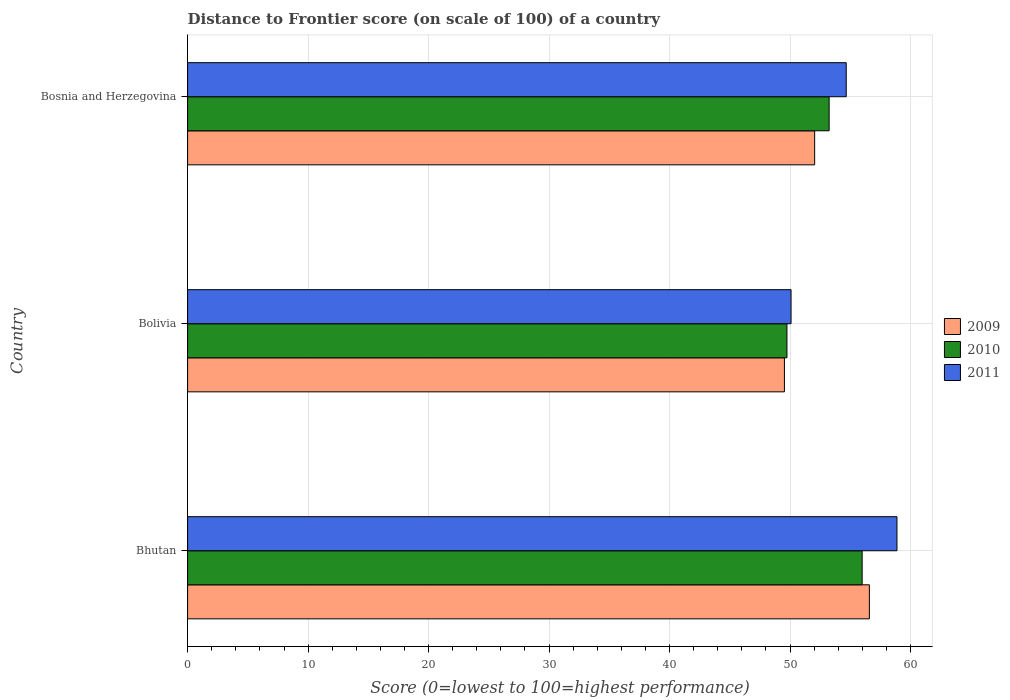How many groups of bars are there?
Give a very brief answer. 3. Are the number of bars per tick equal to the number of legend labels?
Make the answer very short. Yes. Are the number of bars on each tick of the Y-axis equal?
Your answer should be compact. Yes. What is the distance to frontier score of in 2010 in Bolivia?
Give a very brief answer. 49.74. Across all countries, what is the maximum distance to frontier score of in 2010?
Give a very brief answer. 55.98. Across all countries, what is the minimum distance to frontier score of in 2009?
Keep it short and to the point. 49.53. In which country was the distance to frontier score of in 2009 maximum?
Your response must be concise. Bhutan. What is the total distance to frontier score of in 2010 in the graph?
Make the answer very short. 158.96. What is the difference between the distance to frontier score of in 2011 in Bhutan and that in Bolivia?
Ensure brevity in your answer.  8.79. What is the difference between the distance to frontier score of in 2010 in Bhutan and the distance to frontier score of in 2009 in Bosnia and Herzegovina?
Provide a short and direct response. 3.94. What is the average distance to frontier score of in 2011 per country?
Give a very brief answer. 54.54. What is the difference between the distance to frontier score of in 2009 and distance to frontier score of in 2010 in Bolivia?
Make the answer very short. -0.21. What is the ratio of the distance to frontier score of in 2010 in Bolivia to that in Bosnia and Herzegovina?
Your answer should be very brief. 0.93. Is the distance to frontier score of in 2009 in Bhutan less than that in Bosnia and Herzegovina?
Keep it short and to the point. No. Is the difference between the distance to frontier score of in 2009 in Bhutan and Bolivia greater than the difference between the distance to frontier score of in 2010 in Bhutan and Bolivia?
Give a very brief answer. Yes. What is the difference between the highest and the second highest distance to frontier score of in 2010?
Make the answer very short. 2.74. What is the difference between the highest and the lowest distance to frontier score of in 2009?
Your answer should be very brief. 7.05. Is the sum of the distance to frontier score of in 2010 in Bolivia and Bosnia and Herzegovina greater than the maximum distance to frontier score of in 2011 across all countries?
Make the answer very short. Yes. What does the 2nd bar from the bottom in Bolivia represents?
Provide a short and direct response. 2010. How many bars are there?
Keep it short and to the point. 9. How many countries are there in the graph?
Offer a very short reply. 3. What is the difference between two consecutive major ticks on the X-axis?
Give a very brief answer. 10. Does the graph contain grids?
Give a very brief answer. Yes. Where does the legend appear in the graph?
Provide a short and direct response. Center right. How many legend labels are there?
Your answer should be very brief. 3. What is the title of the graph?
Offer a very short reply. Distance to Frontier score (on scale of 100) of a country. Does "1967" appear as one of the legend labels in the graph?
Offer a very short reply. No. What is the label or title of the X-axis?
Offer a terse response. Score (0=lowest to 100=highest performance). What is the Score (0=lowest to 100=highest performance) of 2009 in Bhutan?
Your response must be concise. 56.58. What is the Score (0=lowest to 100=highest performance) of 2010 in Bhutan?
Provide a short and direct response. 55.98. What is the Score (0=lowest to 100=highest performance) in 2011 in Bhutan?
Provide a short and direct response. 58.87. What is the Score (0=lowest to 100=highest performance) in 2009 in Bolivia?
Give a very brief answer. 49.53. What is the Score (0=lowest to 100=highest performance) of 2010 in Bolivia?
Offer a very short reply. 49.74. What is the Score (0=lowest to 100=highest performance) in 2011 in Bolivia?
Offer a terse response. 50.08. What is the Score (0=lowest to 100=highest performance) of 2009 in Bosnia and Herzegovina?
Give a very brief answer. 52.04. What is the Score (0=lowest to 100=highest performance) of 2010 in Bosnia and Herzegovina?
Give a very brief answer. 53.24. What is the Score (0=lowest to 100=highest performance) of 2011 in Bosnia and Herzegovina?
Your response must be concise. 54.66. Across all countries, what is the maximum Score (0=lowest to 100=highest performance) in 2009?
Offer a terse response. 56.58. Across all countries, what is the maximum Score (0=lowest to 100=highest performance) of 2010?
Ensure brevity in your answer.  55.98. Across all countries, what is the maximum Score (0=lowest to 100=highest performance) of 2011?
Your answer should be compact. 58.87. Across all countries, what is the minimum Score (0=lowest to 100=highest performance) of 2009?
Your answer should be compact. 49.53. Across all countries, what is the minimum Score (0=lowest to 100=highest performance) in 2010?
Ensure brevity in your answer.  49.74. Across all countries, what is the minimum Score (0=lowest to 100=highest performance) of 2011?
Your answer should be compact. 50.08. What is the total Score (0=lowest to 100=highest performance) of 2009 in the graph?
Provide a short and direct response. 158.15. What is the total Score (0=lowest to 100=highest performance) of 2010 in the graph?
Your answer should be compact. 158.96. What is the total Score (0=lowest to 100=highest performance) of 2011 in the graph?
Provide a succinct answer. 163.61. What is the difference between the Score (0=lowest to 100=highest performance) of 2009 in Bhutan and that in Bolivia?
Ensure brevity in your answer.  7.05. What is the difference between the Score (0=lowest to 100=highest performance) in 2010 in Bhutan and that in Bolivia?
Provide a succinct answer. 6.24. What is the difference between the Score (0=lowest to 100=highest performance) of 2011 in Bhutan and that in Bolivia?
Your answer should be compact. 8.79. What is the difference between the Score (0=lowest to 100=highest performance) in 2009 in Bhutan and that in Bosnia and Herzegovina?
Offer a very short reply. 4.54. What is the difference between the Score (0=lowest to 100=highest performance) of 2010 in Bhutan and that in Bosnia and Herzegovina?
Keep it short and to the point. 2.74. What is the difference between the Score (0=lowest to 100=highest performance) in 2011 in Bhutan and that in Bosnia and Herzegovina?
Offer a terse response. 4.21. What is the difference between the Score (0=lowest to 100=highest performance) in 2009 in Bolivia and that in Bosnia and Herzegovina?
Your answer should be compact. -2.51. What is the difference between the Score (0=lowest to 100=highest performance) in 2011 in Bolivia and that in Bosnia and Herzegovina?
Provide a short and direct response. -4.58. What is the difference between the Score (0=lowest to 100=highest performance) of 2009 in Bhutan and the Score (0=lowest to 100=highest performance) of 2010 in Bolivia?
Ensure brevity in your answer.  6.84. What is the difference between the Score (0=lowest to 100=highest performance) in 2009 in Bhutan and the Score (0=lowest to 100=highest performance) in 2011 in Bolivia?
Your answer should be compact. 6.5. What is the difference between the Score (0=lowest to 100=highest performance) of 2010 in Bhutan and the Score (0=lowest to 100=highest performance) of 2011 in Bolivia?
Your response must be concise. 5.9. What is the difference between the Score (0=lowest to 100=highest performance) in 2009 in Bhutan and the Score (0=lowest to 100=highest performance) in 2010 in Bosnia and Herzegovina?
Give a very brief answer. 3.34. What is the difference between the Score (0=lowest to 100=highest performance) of 2009 in Bhutan and the Score (0=lowest to 100=highest performance) of 2011 in Bosnia and Herzegovina?
Your answer should be compact. 1.92. What is the difference between the Score (0=lowest to 100=highest performance) of 2010 in Bhutan and the Score (0=lowest to 100=highest performance) of 2011 in Bosnia and Herzegovina?
Make the answer very short. 1.32. What is the difference between the Score (0=lowest to 100=highest performance) in 2009 in Bolivia and the Score (0=lowest to 100=highest performance) in 2010 in Bosnia and Herzegovina?
Offer a terse response. -3.71. What is the difference between the Score (0=lowest to 100=highest performance) of 2009 in Bolivia and the Score (0=lowest to 100=highest performance) of 2011 in Bosnia and Herzegovina?
Offer a very short reply. -5.13. What is the difference between the Score (0=lowest to 100=highest performance) of 2010 in Bolivia and the Score (0=lowest to 100=highest performance) of 2011 in Bosnia and Herzegovina?
Your answer should be very brief. -4.92. What is the average Score (0=lowest to 100=highest performance) of 2009 per country?
Keep it short and to the point. 52.72. What is the average Score (0=lowest to 100=highest performance) of 2010 per country?
Ensure brevity in your answer.  52.99. What is the average Score (0=lowest to 100=highest performance) of 2011 per country?
Give a very brief answer. 54.54. What is the difference between the Score (0=lowest to 100=highest performance) of 2009 and Score (0=lowest to 100=highest performance) of 2011 in Bhutan?
Provide a short and direct response. -2.29. What is the difference between the Score (0=lowest to 100=highest performance) of 2010 and Score (0=lowest to 100=highest performance) of 2011 in Bhutan?
Offer a terse response. -2.89. What is the difference between the Score (0=lowest to 100=highest performance) in 2009 and Score (0=lowest to 100=highest performance) in 2010 in Bolivia?
Keep it short and to the point. -0.21. What is the difference between the Score (0=lowest to 100=highest performance) of 2009 and Score (0=lowest to 100=highest performance) of 2011 in Bolivia?
Give a very brief answer. -0.55. What is the difference between the Score (0=lowest to 100=highest performance) in 2010 and Score (0=lowest to 100=highest performance) in 2011 in Bolivia?
Make the answer very short. -0.34. What is the difference between the Score (0=lowest to 100=highest performance) in 2009 and Score (0=lowest to 100=highest performance) in 2011 in Bosnia and Herzegovina?
Provide a short and direct response. -2.62. What is the difference between the Score (0=lowest to 100=highest performance) in 2010 and Score (0=lowest to 100=highest performance) in 2011 in Bosnia and Herzegovina?
Your answer should be very brief. -1.42. What is the ratio of the Score (0=lowest to 100=highest performance) of 2009 in Bhutan to that in Bolivia?
Your answer should be compact. 1.14. What is the ratio of the Score (0=lowest to 100=highest performance) of 2010 in Bhutan to that in Bolivia?
Offer a very short reply. 1.13. What is the ratio of the Score (0=lowest to 100=highest performance) of 2011 in Bhutan to that in Bolivia?
Provide a short and direct response. 1.18. What is the ratio of the Score (0=lowest to 100=highest performance) in 2009 in Bhutan to that in Bosnia and Herzegovina?
Your answer should be compact. 1.09. What is the ratio of the Score (0=lowest to 100=highest performance) of 2010 in Bhutan to that in Bosnia and Herzegovina?
Offer a very short reply. 1.05. What is the ratio of the Score (0=lowest to 100=highest performance) of 2011 in Bhutan to that in Bosnia and Herzegovina?
Keep it short and to the point. 1.08. What is the ratio of the Score (0=lowest to 100=highest performance) in 2009 in Bolivia to that in Bosnia and Herzegovina?
Provide a succinct answer. 0.95. What is the ratio of the Score (0=lowest to 100=highest performance) of 2010 in Bolivia to that in Bosnia and Herzegovina?
Offer a very short reply. 0.93. What is the ratio of the Score (0=lowest to 100=highest performance) of 2011 in Bolivia to that in Bosnia and Herzegovina?
Your answer should be compact. 0.92. What is the difference between the highest and the second highest Score (0=lowest to 100=highest performance) in 2009?
Provide a short and direct response. 4.54. What is the difference between the highest and the second highest Score (0=lowest to 100=highest performance) in 2010?
Your response must be concise. 2.74. What is the difference between the highest and the second highest Score (0=lowest to 100=highest performance) in 2011?
Make the answer very short. 4.21. What is the difference between the highest and the lowest Score (0=lowest to 100=highest performance) of 2009?
Provide a succinct answer. 7.05. What is the difference between the highest and the lowest Score (0=lowest to 100=highest performance) of 2010?
Provide a short and direct response. 6.24. What is the difference between the highest and the lowest Score (0=lowest to 100=highest performance) of 2011?
Provide a short and direct response. 8.79. 